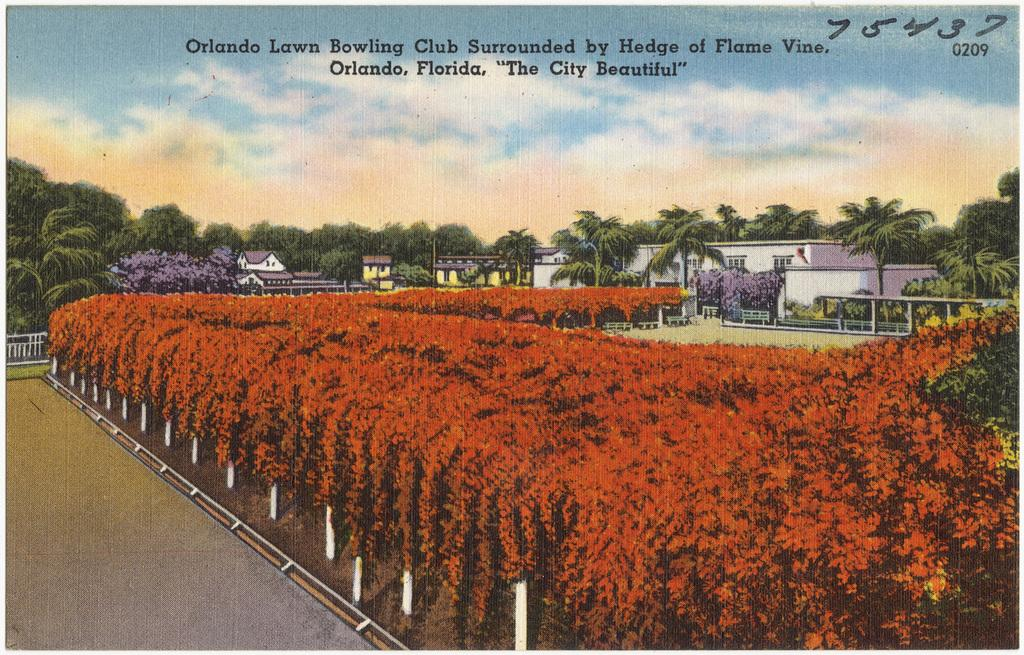What is located in the middle of the image? There are plants in the middle of the image. What type of structures can be seen on the right side of the image? There are houses on the right side of the image. What is visible at the top of the image? The sky is visible at the top of the image. How many eggs are present in the image? There are no eggs present in the image. What type of test can be seen being conducted in the image? There is no test being conducted in the image. 